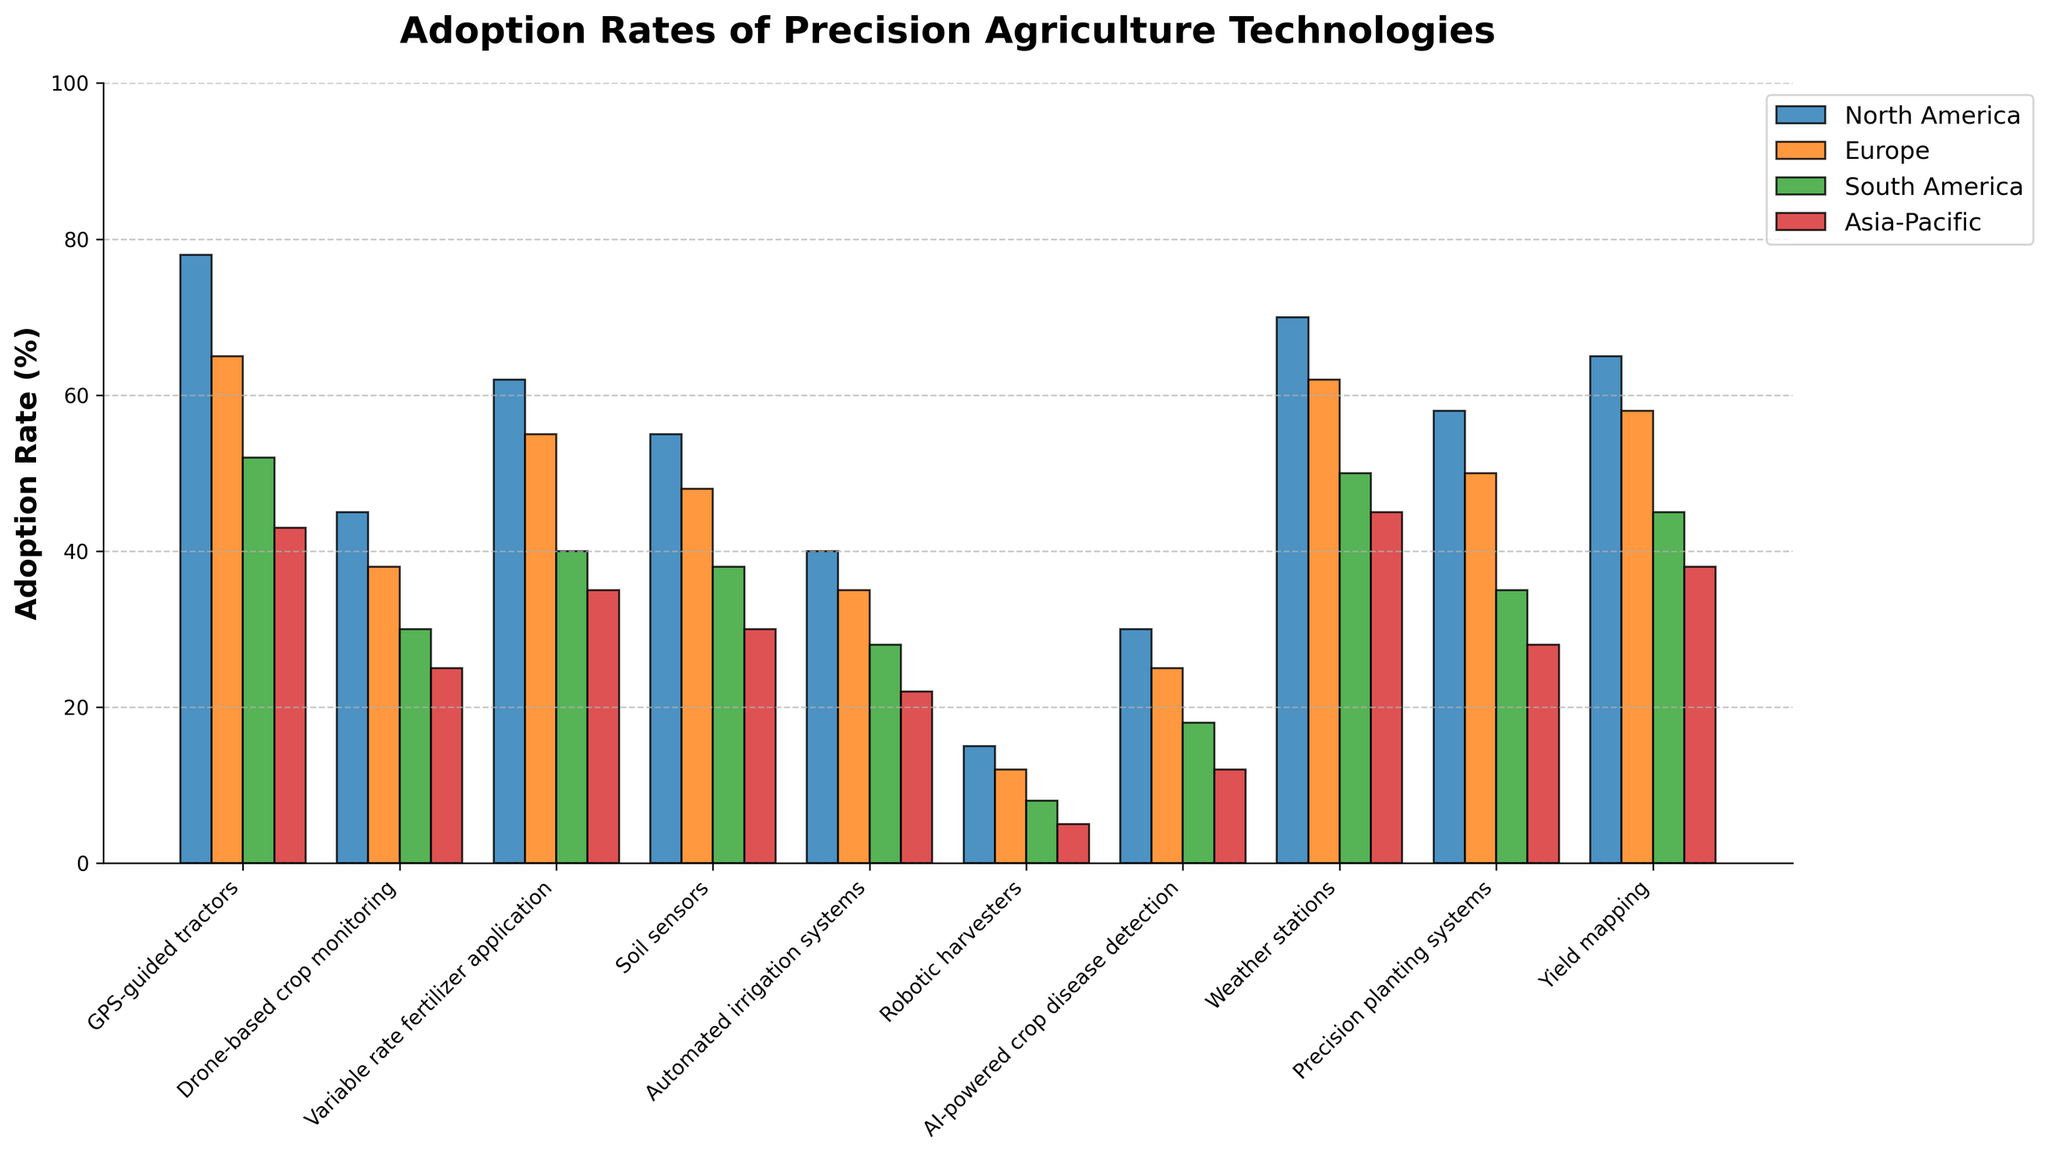What is the average adoption rate of GPS-guided tractors across all regions? First, sum the adoption rates for GPS-guided tractors in North America (78), Europe (65), South America (52), and Asia-Pacific (43). The total is 78 + 65 + 52 + 43 = 238. Then, divide this sum by the number of regions, which is 4. The average is 238 / 4 = 59.5
Answer: 59.5 Which region has the highest adoption rate for drone-based crop monitoring? Compare the adoption rates of drone-based crop monitoring across all regions. North America has 45%, Europe has 38%, South America has 30%, and Asia-Pacific has 25%. North America has the highest adoption rate at 45%.
Answer: North America Is the adoption rate of soil sensors higher or lower than weather stations in Europe? For Europe, check the adoption rates of soil sensors (48%) and weather stations (62%). Soil sensors have a lower adoption rate than weather stations.
Answer: Lower How much greater is the adoption rate of yield mapping in North America compared to Asia-Pacific? Identify the adoption rates of yield mapping in North America (65%) and Asia-Pacific (38%). Subtract the adoption rate of Asia-Pacific from the adoption rate of North America: 65 - 38 = 27.
Answer: 27 What is the total adoption rate of automated irrigation systems across all regions? Add up the adoption rates of automated irrigation systems in North America (40%), Europe (35%), South America (28%), and Asia-Pacific (22%). The total is 40 + 35 + 28 + 22 = 125.
Answer: 125 Which technology has the second-lowest adoption rate in Asia-Pacific? Compare the adoption rates of all technologies in Asia-Pacific. The adoption rates are: GPS-guided tractors (43), Drone-based crop monitoring (25), Variable rate fertilizer application (35), Soil sensors (30), Automated irrigation systems (22), Robotic harvesters (5), AI-powered crop disease detection (12), Weather stations (45), Precision planting systems (28), Yield mapping (38). The second-lowest value after 5 (Robotic harvesters) is 12 (AI-powered crop disease detection).
Answer: AI-powered crop disease detection Are there any technologies where Europe has a higher adoption rate than North America? Compare the adoption rates of all technologies between Europe and North America. None of the technologies have a higher adoption rate in Europe than in North America.
Answer: No What is the difference in adoption rates of robotic harvesters between North America and South America? Compare the adoption rates of robotic harvesters in North America (15%) and South America (8%). Subtract the adoption rate of South America from North America: 15 - 8 = 7.
Answer: 7 Is the adoption rate for precision planting systems in South America greater than for automated irrigation systems in Europe? Compare the adoption rates of precision planting systems in South America (35%) with automated irrigation systems in Europe (35%). Both technologies have the same adoption rate.
Answer: Equal What is the combined adoption rate of GPS-guided tractors and variable rate fertilizer application in North America? Sum the adoption rates of GPS-guided tractors (78%) and variable rate fertilizer application (62%) in North America. The total is 78 + 62 = 140.
Answer: 140 